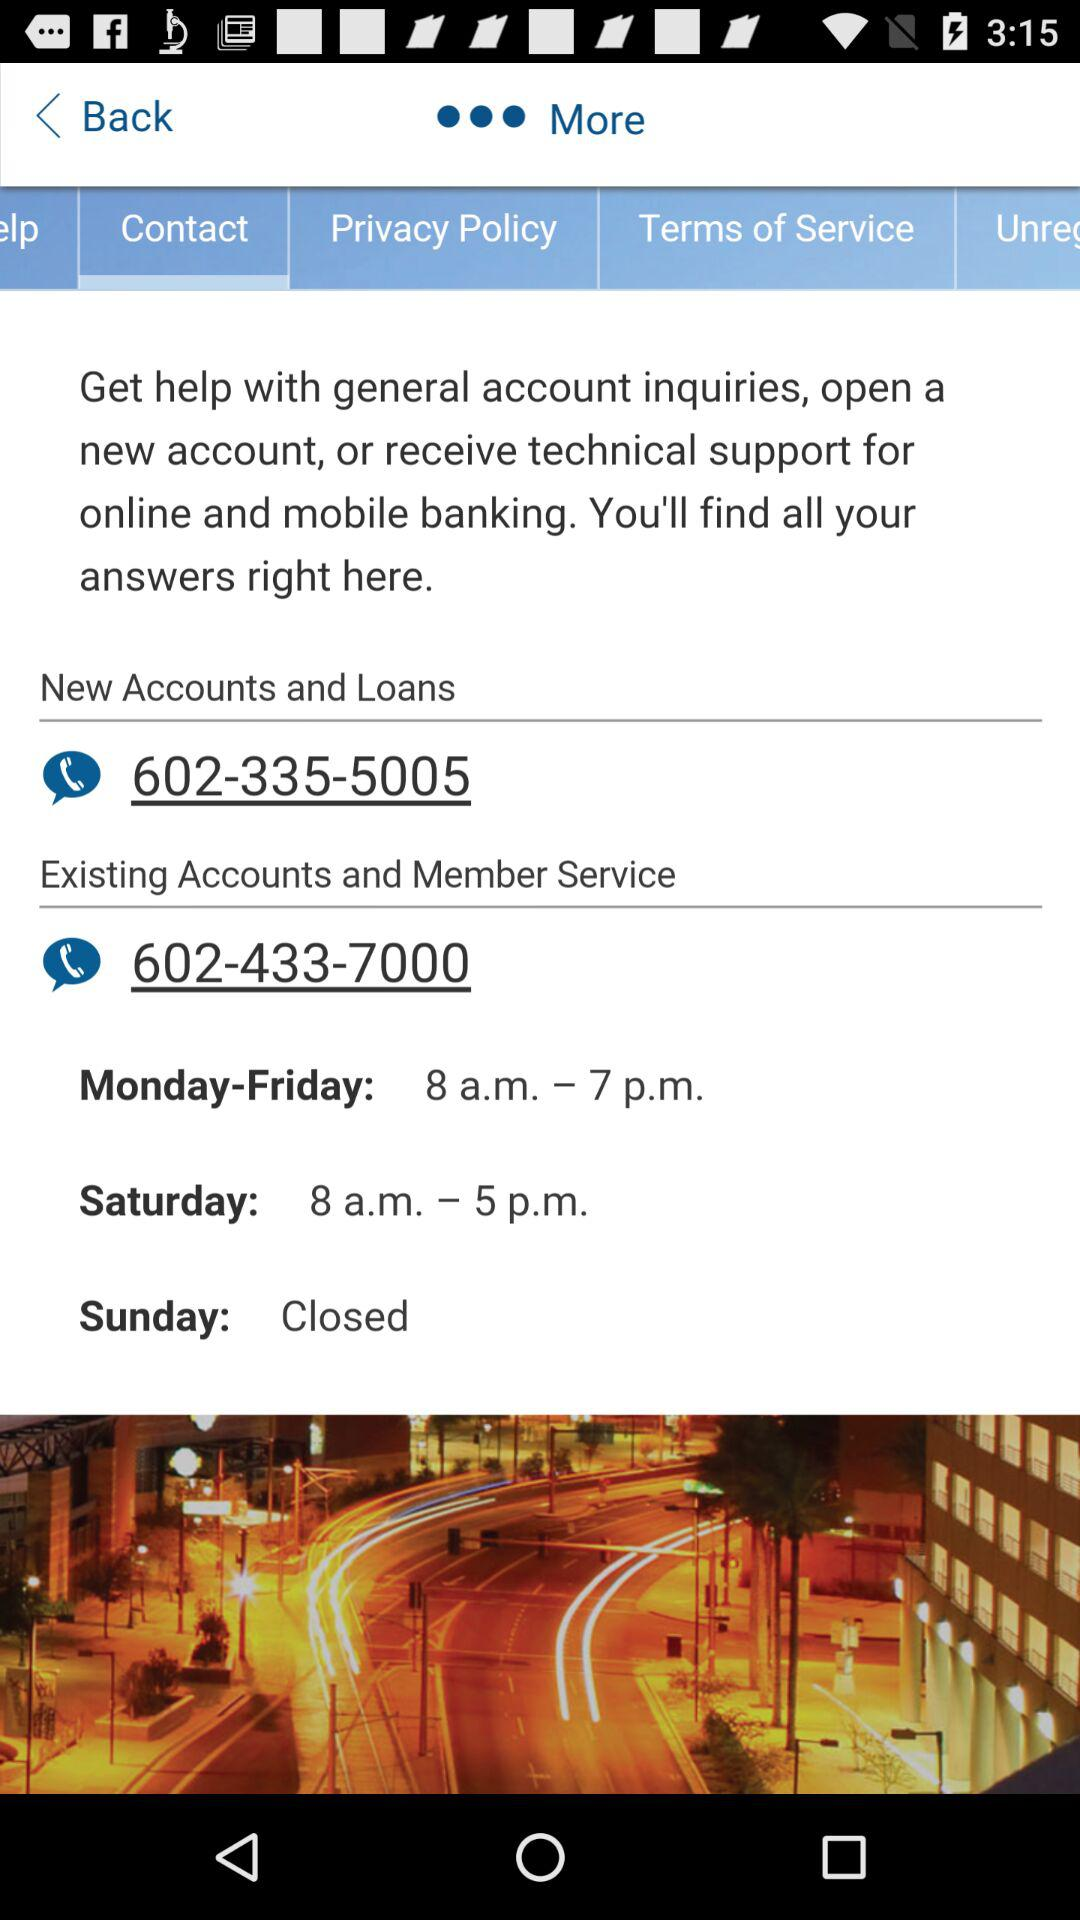What's the opening time? The opening time is 8 a.m. 